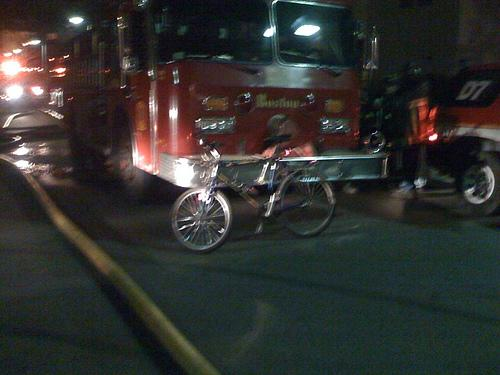Pick a task: multi-choice VQA or product advertisement. Offer a description focusing on an object and its features. Product advertisement: Experience the premium quality and performance of our silver chrome bicycle, featuring sturdy front and rear tires for a smooth ride in any environment. List the most prominent objects in the image and their characteristics. There is a silver bicycle with front and rear tires, a red fire truck with a windshield, a yellow fire hose, and a worker in a safety vest. Select a task: visual entailment or referential expression grounding. Then, comment on the presence of a certain object and its characteristics. Visual entailment: A silver chrome bicycle is present along with a front and rear bicycle tire. Mention any object lying on the ground along with its color and what it is used for. A yellow fire hose is on the ground, which is used for extinguishing fires. Identify any emergency service related objects and give specific details on their colors and appearance. A red fire engine with a windshield and front right tire, a yellow fire hose, and a worker in a safety vest are present in the image. What can be seen in the background and how does it contrast with the main subject? Bright lights are in the background, contrasting with the main subject of the silver bicycle and red fire truck in the foreground. Comment on the visibility of any people in the image and their appearance. Fire men are present but appear blurred in the image, and a worker in a safety vest can be seen clearly. What type of vehicle is in the picture and what color is it? A red fire truck is visible in the photo. Explain the time of day the photo was taken and what clues in the image provide this information. The photo was taken at night, as evidenced by the dark sky and bright lights in the background. What is the primary focus of the image and describe any reflections visible. The primary focus is a silver bicycle, and light is reflecting off of it and the fire truck's windshield. 